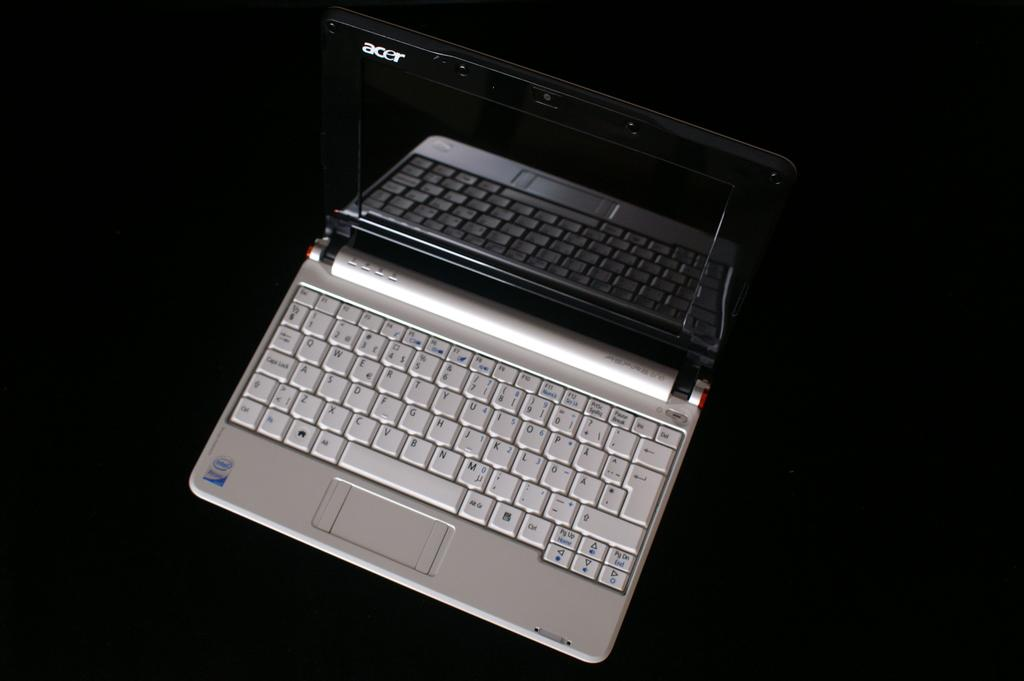<image>
Give a short and clear explanation of the subsequent image. QWERTY standard keys are shown on this open laptop. 